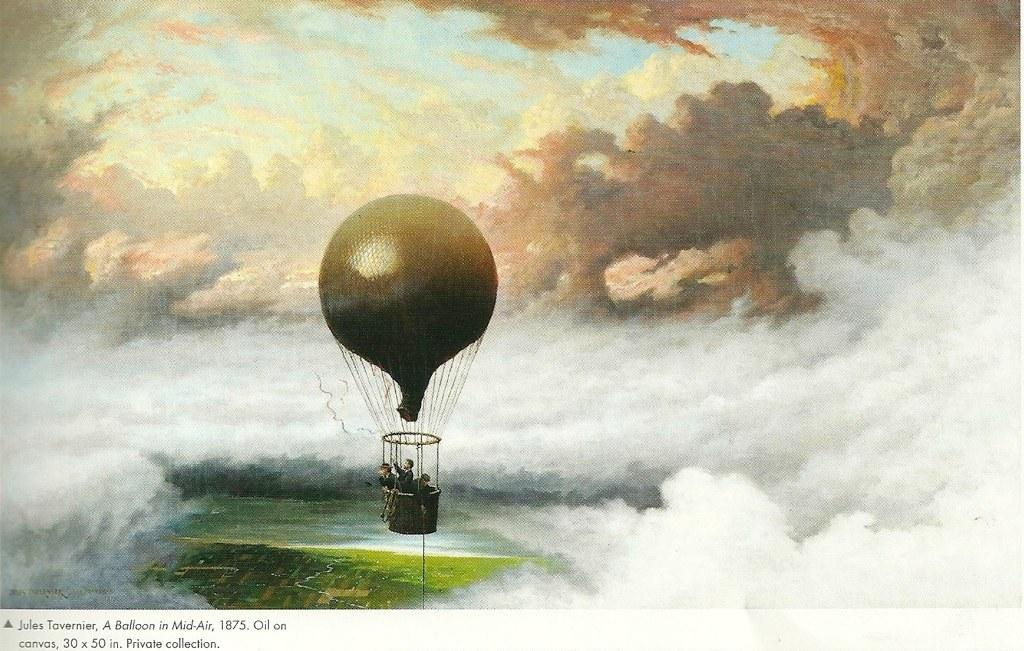What type of art is featured in the image? The image contains an art piece. What is the subject matter of the art piece? The art piece depicts clouds. Are there any additional elements in the art piece besides clouds? Yes, the art piece includes a gas balloon. What type of juice is being distributed from the ball in the image? There is no ball or juice present in the image; it features an art piece depicting clouds and a gas balloon. 